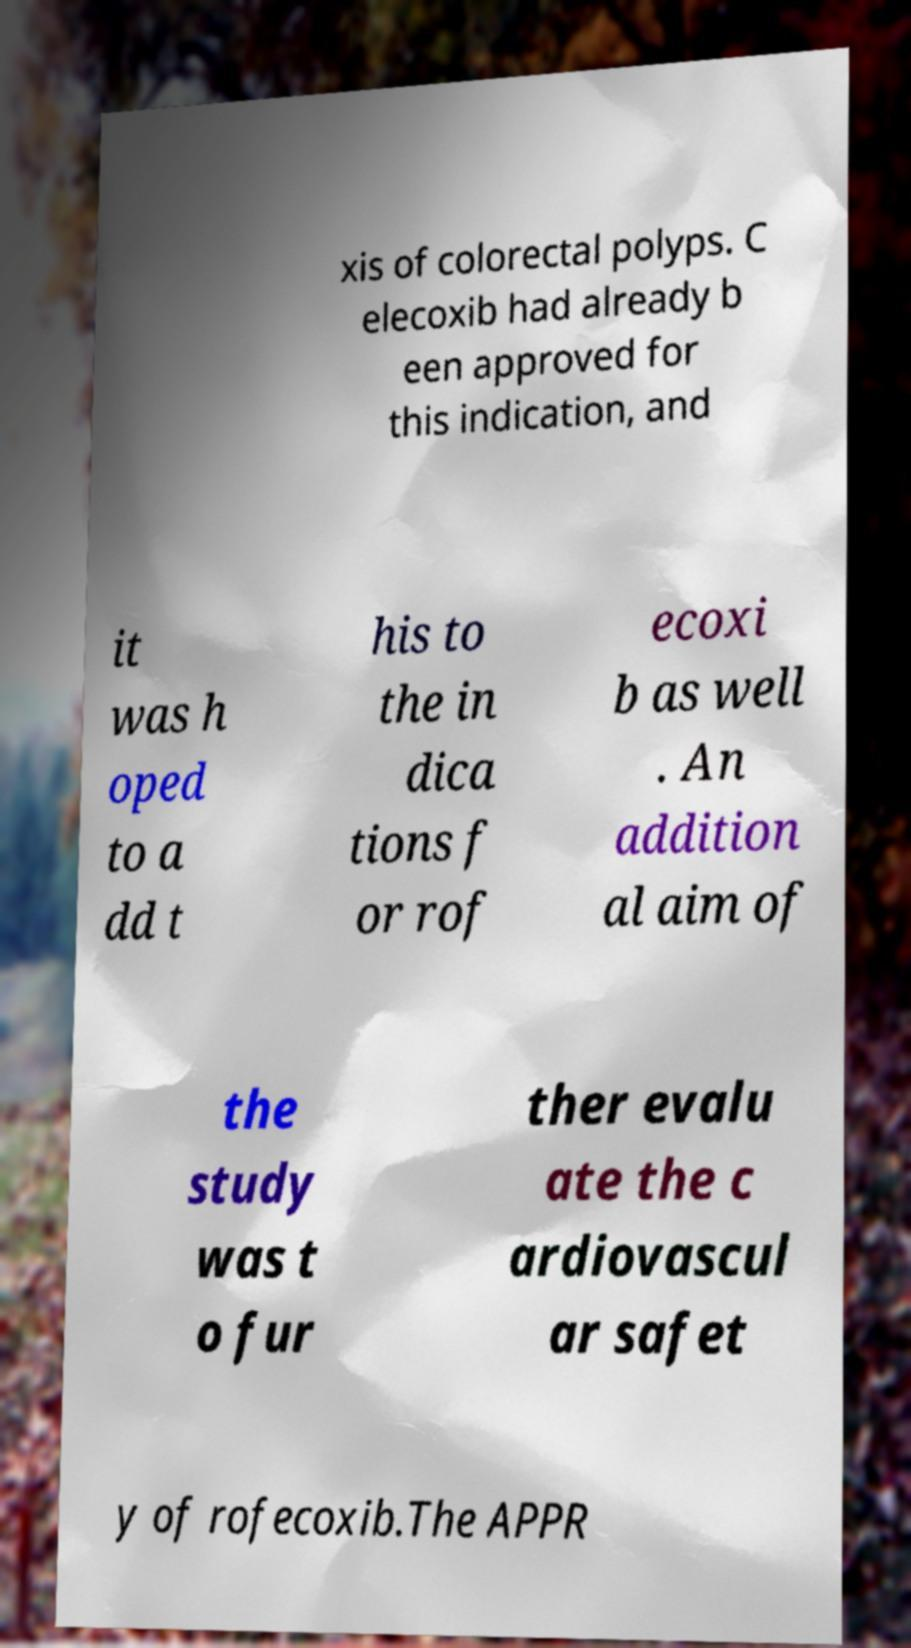Please read and relay the text visible in this image. What does it say? xis of colorectal polyps. C elecoxib had already b een approved for this indication, and it was h oped to a dd t his to the in dica tions f or rof ecoxi b as well . An addition al aim of the study was t o fur ther evalu ate the c ardiovascul ar safet y of rofecoxib.The APPR 